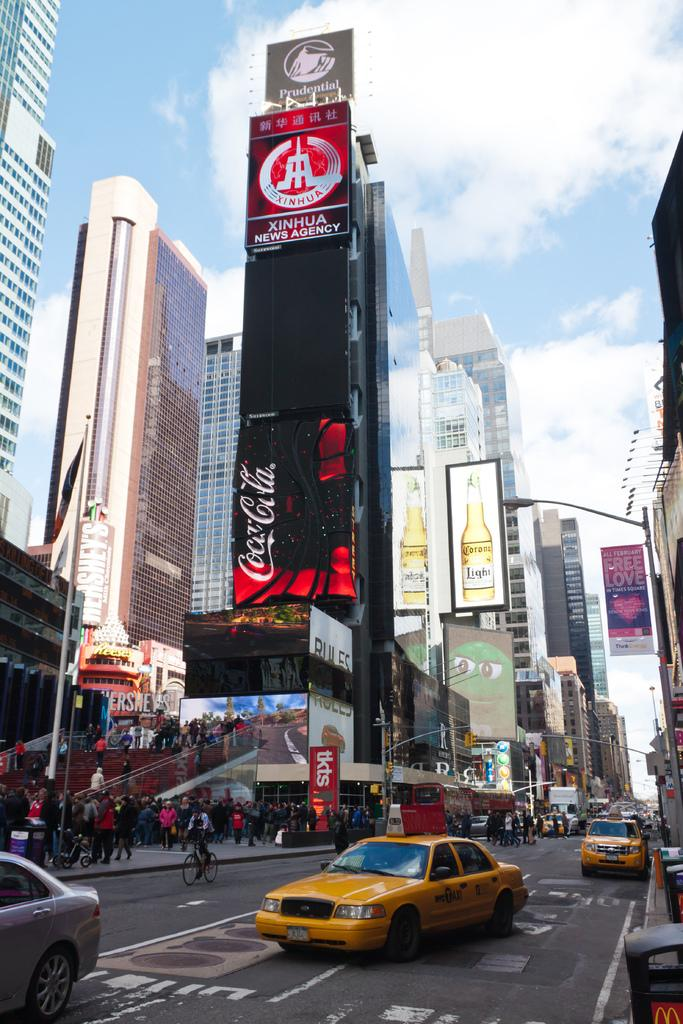<image>
Provide a brief description of the given image. A TALL BUILDING WITH A COCA COLA BILLBOARD ON THE SIDE OF IT. 